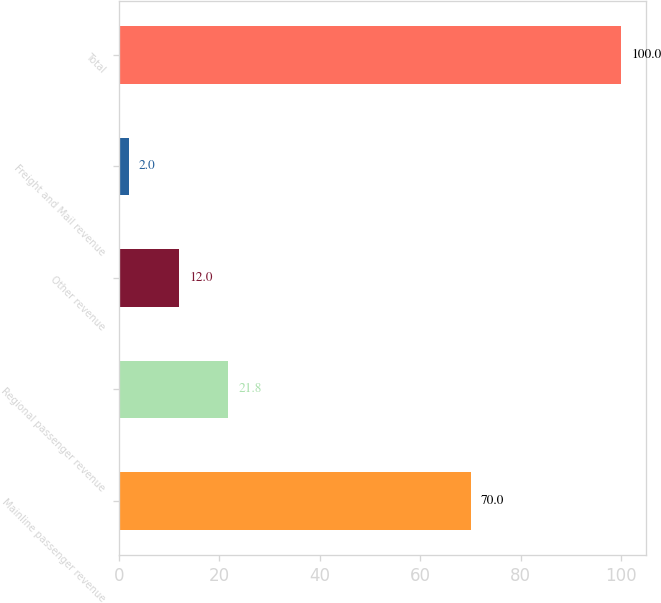Convert chart. <chart><loc_0><loc_0><loc_500><loc_500><bar_chart><fcel>Mainline passenger revenue<fcel>Regional passenger revenue<fcel>Other revenue<fcel>Freight and Mail revenue<fcel>Total<nl><fcel>70<fcel>21.8<fcel>12<fcel>2<fcel>100<nl></chart> 